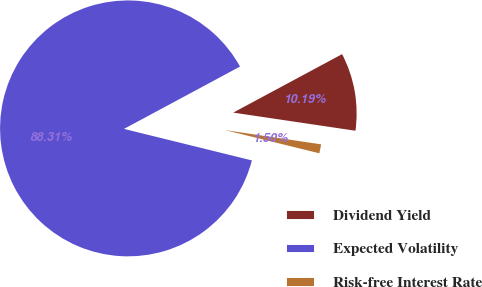<chart> <loc_0><loc_0><loc_500><loc_500><pie_chart><fcel>Dividend Yield<fcel>Expected Volatility<fcel>Risk-free Interest Rate<nl><fcel>10.19%<fcel>88.31%<fcel>1.5%<nl></chart> 